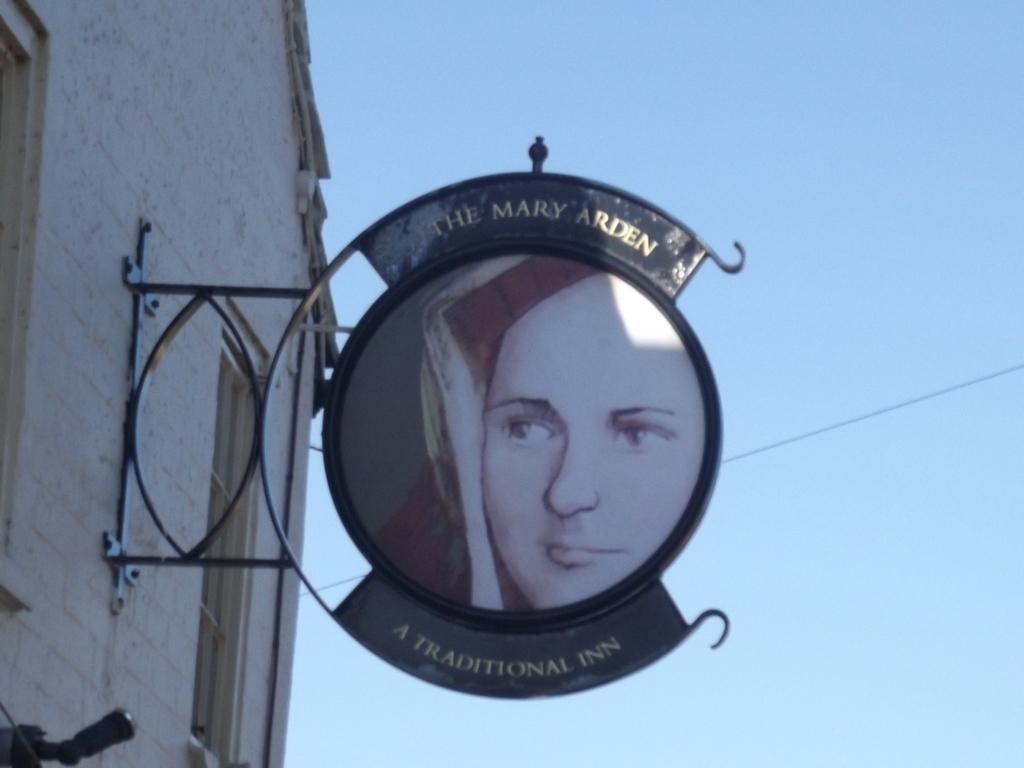Could you give a brief overview of what you see in this image? In this picture I can see a building on the left side and I can see a board and on it I can see the depiction picture of a woman and I see something is written. In the background I can see the clear sky and I can see a wire. 